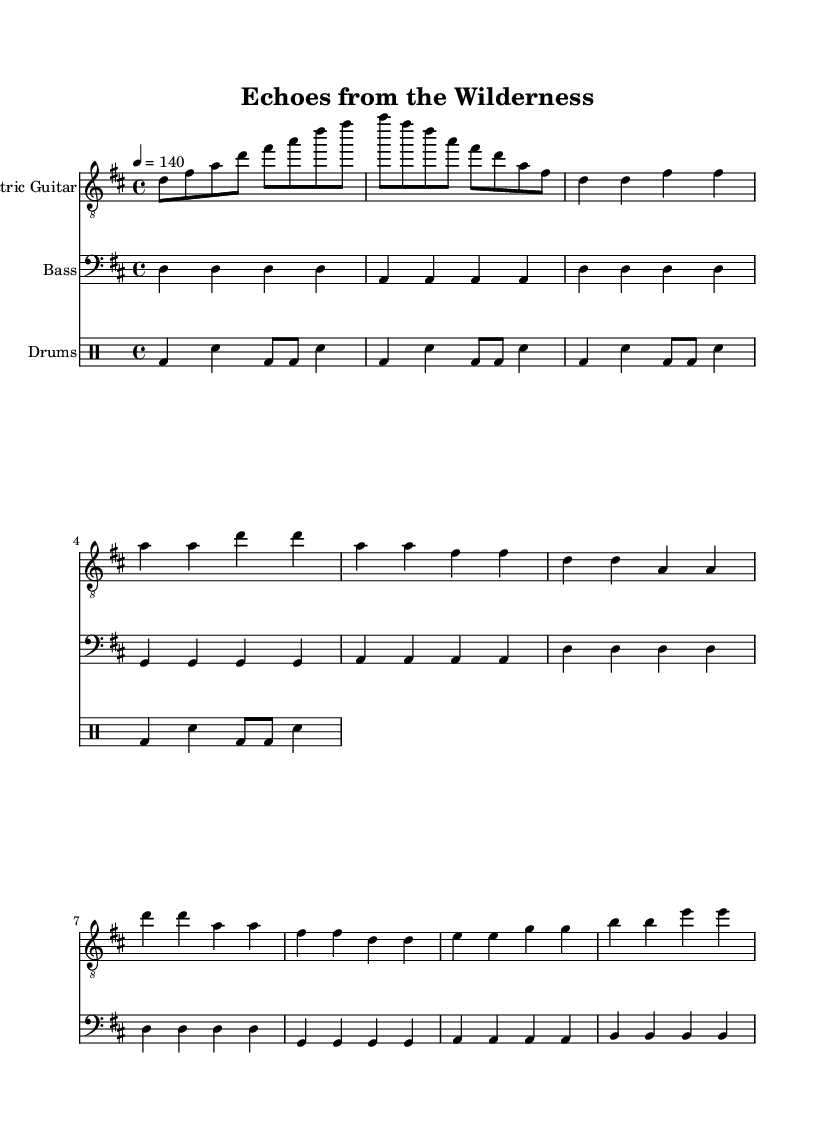What is the key signature of this music? The key signature is D major, which has two sharps (F# and C#). This is indicated at the beginning of the staff where the sharps are represented.
Answer: D major What is the time signature of this music? The time signature is 4/4, which means there are four beats in each measure and the quarter note gets one beat. This is found at the beginning of the score.
Answer: 4/4 What is the tempo marking for this piece? The tempo marking is indicated as a number (140) with a quarter note equals 4, which means the piece should be played at a steady pace of 140 beats per minute.
Answer: 140 How many measures are in the chorus section? By counting the measures in the chorus part of the score, we find there are four measures. This requires reviewing the notation in the corresponding section labeled as "Chorus."
Answer: 4 What type of guitar is indicated in this piece? The instrument specified is "Electric Guitar," which is shown at the beginning of the staff. This designation states the type of guitar for which the part is written.
Answer: Electric Guitar What is the primary drum pattern used in this piece? The primary drum pattern consists of a bass drum (bd), snare drum (sn), and the notation reveals a standard punk beat that typically alternates bass and snare through eighth and quarter notes. This is determined by analyzing the drum part's rhythmic construction.
Answer: Basic punk beat 